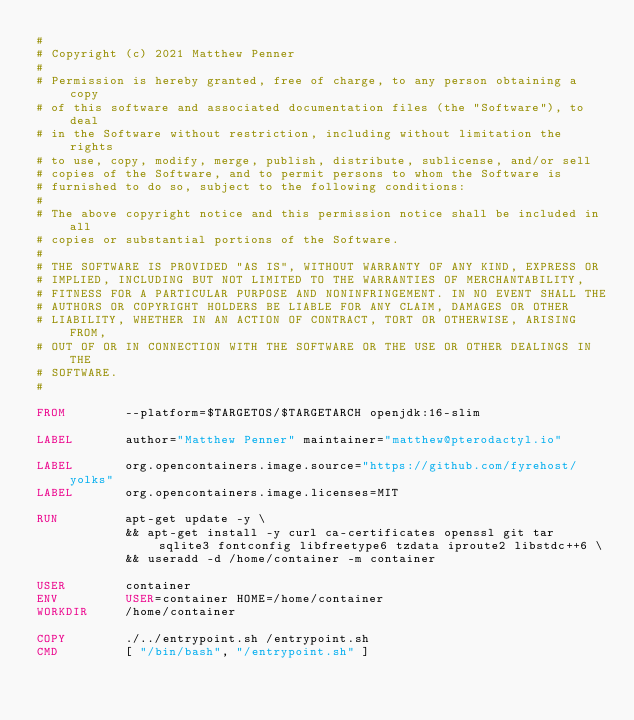<code> <loc_0><loc_0><loc_500><loc_500><_Dockerfile_>#
# Copyright (c) 2021 Matthew Penner
#
# Permission is hereby granted, free of charge, to any person obtaining a copy
# of this software and associated documentation files (the "Software"), to deal
# in the Software without restriction, including without limitation the rights
# to use, copy, modify, merge, publish, distribute, sublicense, and/or sell
# copies of the Software, and to permit persons to whom the Software is
# furnished to do so, subject to the following conditions:
#
# The above copyright notice and this permission notice shall be included in all
# copies or substantial portions of the Software.
#
# THE SOFTWARE IS PROVIDED "AS IS", WITHOUT WARRANTY OF ANY KIND, EXPRESS OR
# IMPLIED, INCLUDING BUT NOT LIMITED TO THE WARRANTIES OF MERCHANTABILITY,
# FITNESS FOR A PARTICULAR PURPOSE AND NONINFRINGEMENT. IN NO EVENT SHALL THE
# AUTHORS OR COPYRIGHT HOLDERS BE LIABLE FOR ANY CLAIM, DAMAGES OR OTHER
# LIABILITY, WHETHER IN AN ACTION OF CONTRACT, TORT OR OTHERWISE, ARISING FROM,
# OUT OF OR IN CONNECTION WITH THE SOFTWARE OR THE USE OR OTHER DEALINGS IN THE
# SOFTWARE.
#

FROM        --platform=$TARGETOS/$TARGETARCH openjdk:16-slim

LABEL       author="Matthew Penner" maintainer="matthew@pterodactyl.io"

LABEL       org.opencontainers.image.source="https://github.com/fyrehost/yolks"
LABEL       org.opencontainers.image.licenses=MIT

RUN 		apt-get update -y \
 			&& apt-get install -y curl ca-certificates openssl git tar sqlite3 fontconfig libfreetype6 tzdata iproute2 libstdc++6 \
 			&& useradd -d /home/container -m container

USER        container
ENV         USER=container HOME=/home/container
WORKDIR     /home/container

COPY        ./../entrypoint.sh /entrypoint.sh
CMD         [ "/bin/bash", "/entrypoint.sh" ]
</code> 